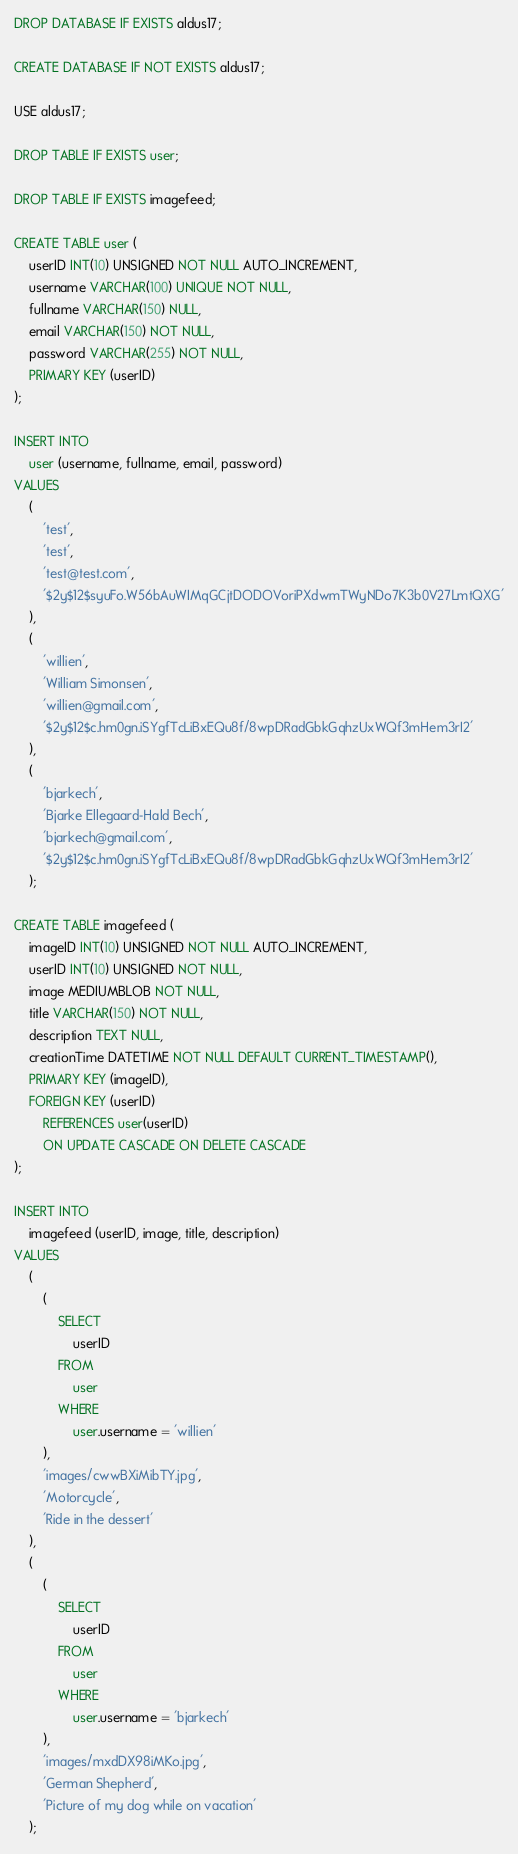<code> <loc_0><loc_0><loc_500><loc_500><_SQL_>DROP DATABASE IF EXISTS aldus17;

CREATE DATABASE IF NOT EXISTS aldus17;

USE aldus17;

DROP TABLE IF EXISTS user;

DROP TABLE IF EXISTS imagefeed;

CREATE TABLE user (
	userID INT(10) UNSIGNED NOT NULL AUTO_INCREMENT,
	username VARCHAR(100) UNIQUE NOT NULL,
	fullname VARCHAR(150) NULL,
	email VARCHAR(150) NOT NULL,
	password VARCHAR(255) NOT NULL,
	PRIMARY KEY (userID)
);

INSERT INTO
	user (username, fullname, email, password)
VALUES
	(
		'test',
		'test',
		'test@test.com',
		'$2y$12$syuFo.W56bAuWIMqGCjtDODOVoriPXdwmTWyNDo7K3b0V27LmtQXG'
	),
	(
		'willien',
		'William Simonsen',
		'willien@gmail.com',
		'$2y$12$c.hm0gn.iSYgfTcLiBxEQu8f/8wpDRadGbkGqhzUxWQf3mHem3rI2'
	),
	(
		'bjarkech',
		'Bjarke Ellegaard-Hald Bech',
		'bjarkech@gmail.com',
		'$2y$12$c.hm0gn.iSYgfTcLiBxEQu8f/8wpDRadGbkGqhzUxWQf3mHem3rI2'
	);

CREATE TABLE imagefeed (
	imageID INT(10) UNSIGNED NOT NULL AUTO_INCREMENT,
	userID INT(10) UNSIGNED NOT NULL,
	image MEDIUMBLOB NOT NULL,
	title VARCHAR(150) NOT NULL,
	description TEXT NULL,
	creationTime DATETIME NOT NULL DEFAULT CURRENT_TIMESTAMP(),
	PRIMARY KEY (imageID),
	FOREIGN KEY (userID) 
		REFERENCES user(userID) 
		ON UPDATE CASCADE ON DELETE CASCADE
);

INSERT INTO
	imagefeed (userID, image, title, description)
VALUES
	(
		(
			SELECT
				userID
			FROM
				user
			WHERE
				user.username = 'willien'
		),
		'images/cwwBXiMibTY.jpg',
		'Motorcycle',
		'Ride in the dessert'
	),
	(
		(
			SELECT
				userID
			FROM
				user
			WHERE
				user.username = 'bjarkech'
		),
		'images/mxdDX98iMKo.jpg',
		'German Shepherd',
		'Picture of my dog while on vacation'
	);</code> 